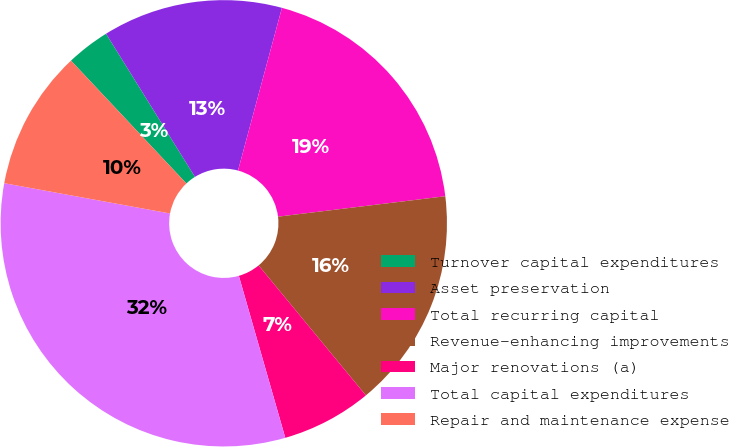Convert chart. <chart><loc_0><loc_0><loc_500><loc_500><pie_chart><fcel>Turnover capital expenditures<fcel>Asset preservation<fcel>Total recurring capital<fcel>Revenue-enhancing improvements<fcel>Major renovations (a)<fcel>Total capital expenditures<fcel>Repair and maintenance expense<nl><fcel>3.16%<fcel>13.04%<fcel>18.87%<fcel>15.95%<fcel>6.54%<fcel>32.32%<fcel>10.12%<nl></chart> 